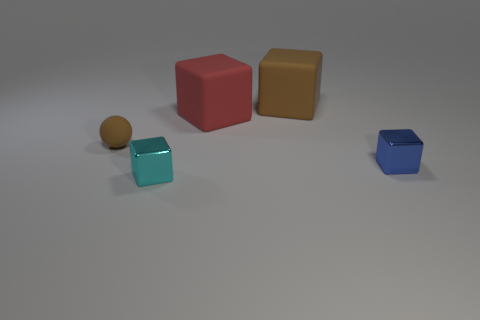Subtract all brown cubes. How many cubes are left? 3 Subtract all big brown matte blocks. How many blocks are left? 3 Subtract all gray blocks. Subtract all red cylinders. How many blocks are left? 4 Add 2 brown rubber blocks. How many objects exist? 7 Subtract all balls. How many objects are left? 4 Add 1 blue metal things. How many blue metal things exist? 2 Subtract 0 cyan spheres. How many objects are left? 5 Subtract all small rubber objects. Subtract all purple rubber cubes. How many objects are left? 4 Add 2 blue blocks. How many blue blocks are left? 3 